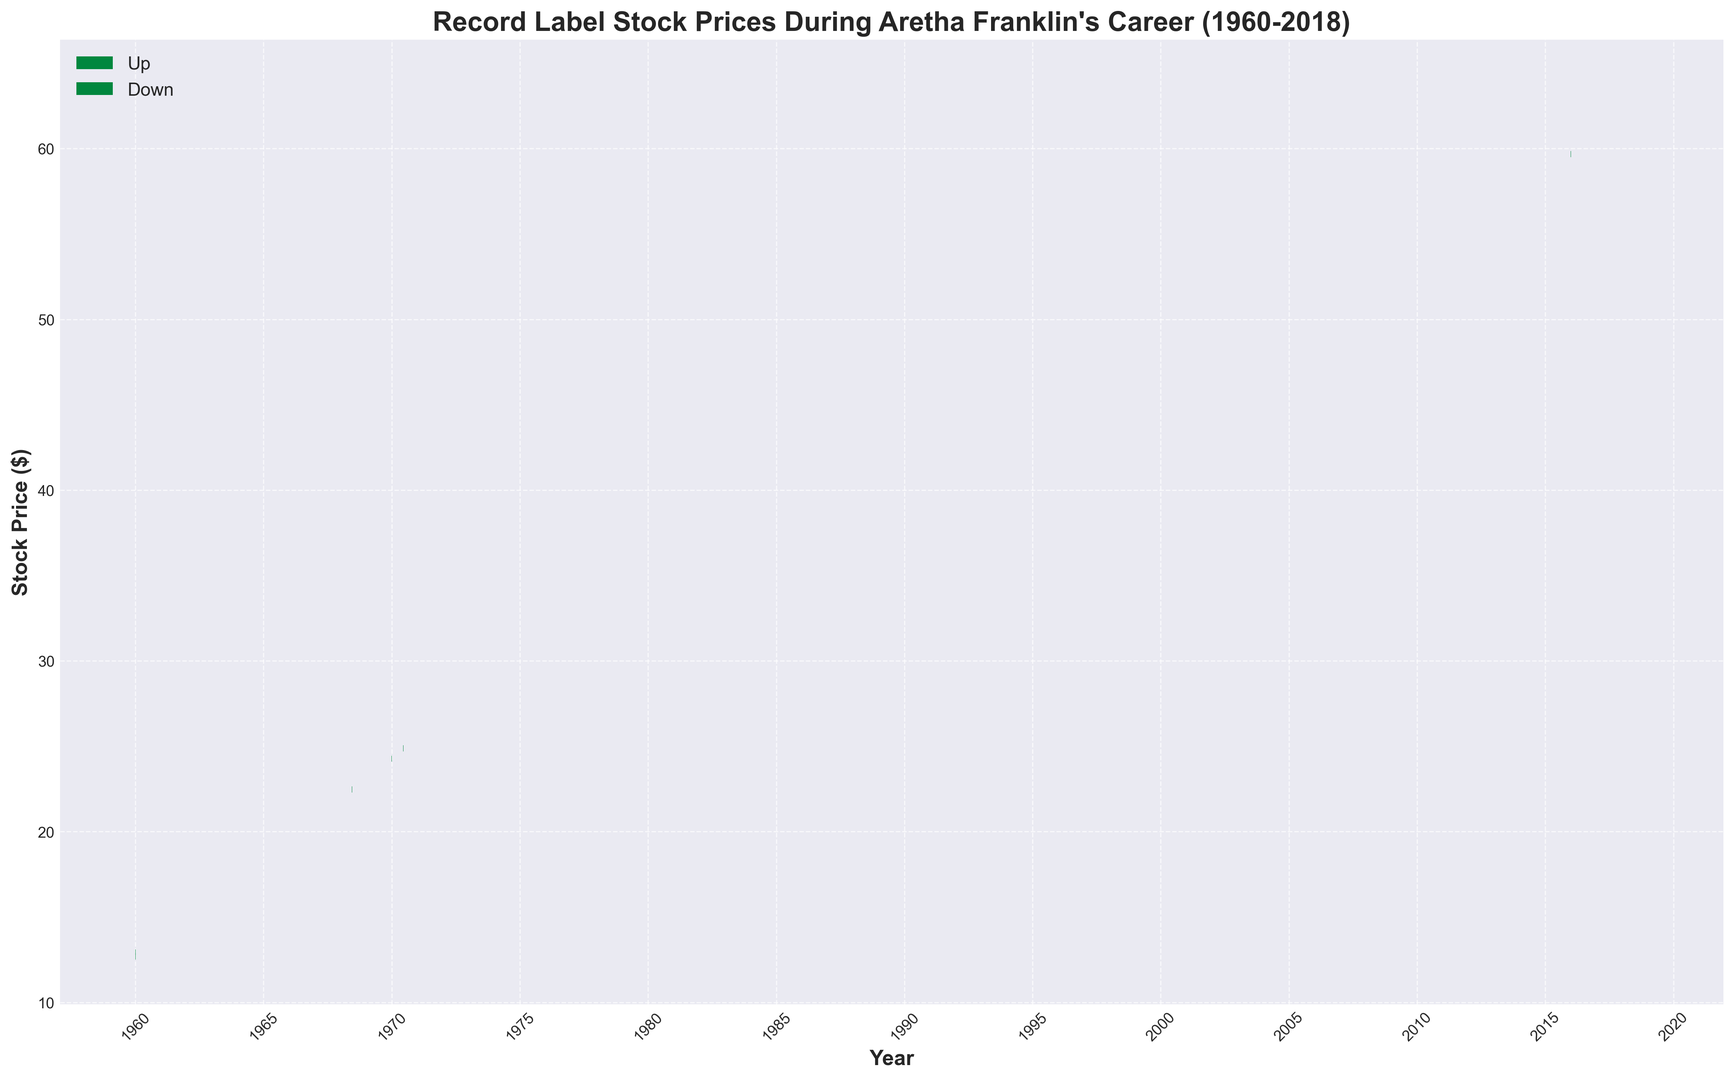Which year showed the highest closing stock price during Aretha Franklin's career? By observing the highest point on the y-axis where the green or red bar closes, we find that the stock price reached its peak in 2018, at the closing price of around $63.65.
Answer: 2018 During which period did the stock price have the greatest increase in closing price from one instance to the next? Identify the differences between each closed stock price over the given periods. The largest increase is between 1970 (around $25.65) and 1975 (around $28.85), which is a rise of about $3.20.
Answer: 1970-1975 How many times did the stock price close higher than it opened during this period? Green bars indicate periods where the closing price was higher than the opening price. Count the number of such bars visually. There are 29 green bars.
Answer: 29 How many periods show a decreasing trend in stock prices? Red bars represent periods where the closing price was lower than the opening price. Count the number of such bars visually. There are 10 red bars.
Answer: 10 What was the closing stock price difference between the start and end of Aretha Franklin's career? The closing stock price at the start (1960) was around $13.10, and at the end (2018) it was around $63.65. The difference is $63.65 - $13.10 = $50.55.
Answer: $50.55 Did the stock price ever fall below $10? Review the figure for any points below the $10 mark on the y-axis. None of the points fall below this mark. Therefore, the stock price has not fallen below $10 during the specified period.
Answer: No In which decade did the stock price experience the least volatility (difference between highs and lows is minimal)? Compare the height variations of bars within each decade. The smallest difference between high and low seems to be in the decade of the 1980s, as the bars are more uniform and less variable.
Answer: 1980s 